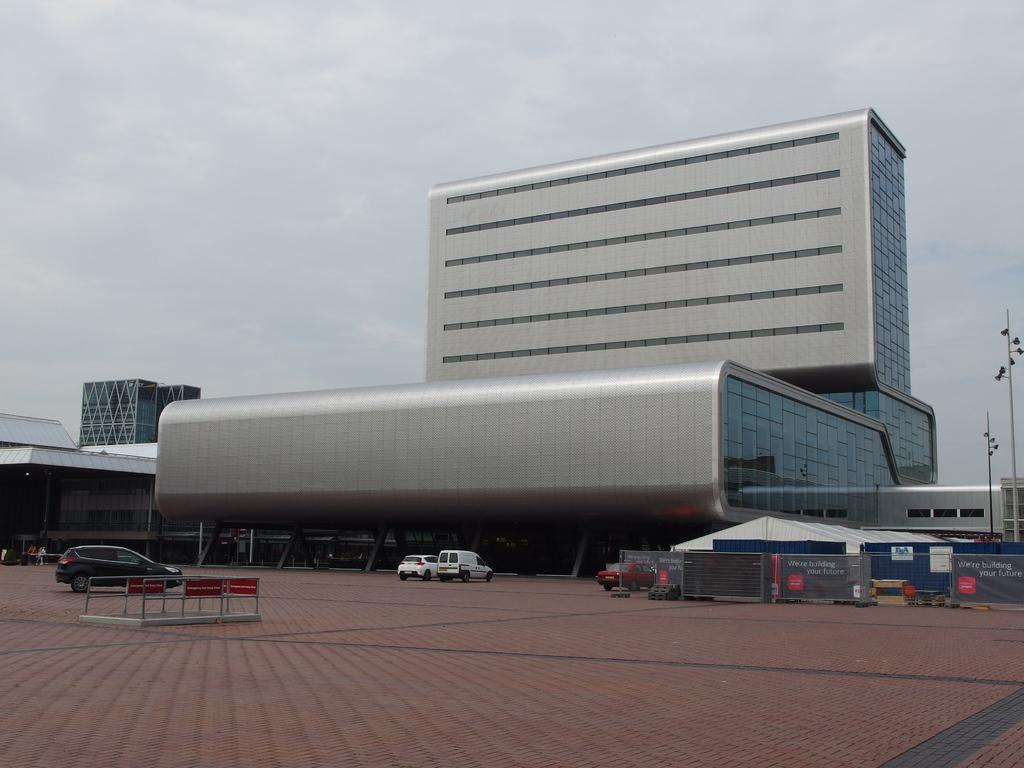What can be seen in the foreground of the image? There is a path for walking in the foreground of the image. What is happening on the path in the image? Vehicles are moving on the path. What can be seen in the background of the image? There is fencing, a shed, a building, a pole, and the sky visible in the background of the image. What type of beef is being served at the shed in the image? There is no mention of beef or any food in the image; it only shows a path, vehicles, and various structures in the background. What statement is being made by the frog in the image? There is no frog present in the image, so it is not possible to determine any statement made by a frog. 